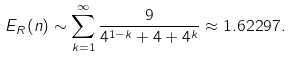<formula> <loc_0><loc_0><loc_500><loc_500>E _ { R } ( n ) \sim \sum _ { k = 1 } ^ { \infty } \frac { 9 } { 4 ^ { 1 - k } + 4 + 4 ^ { k } } \approx 1 . 6 2 2 9 7 .</formula> 